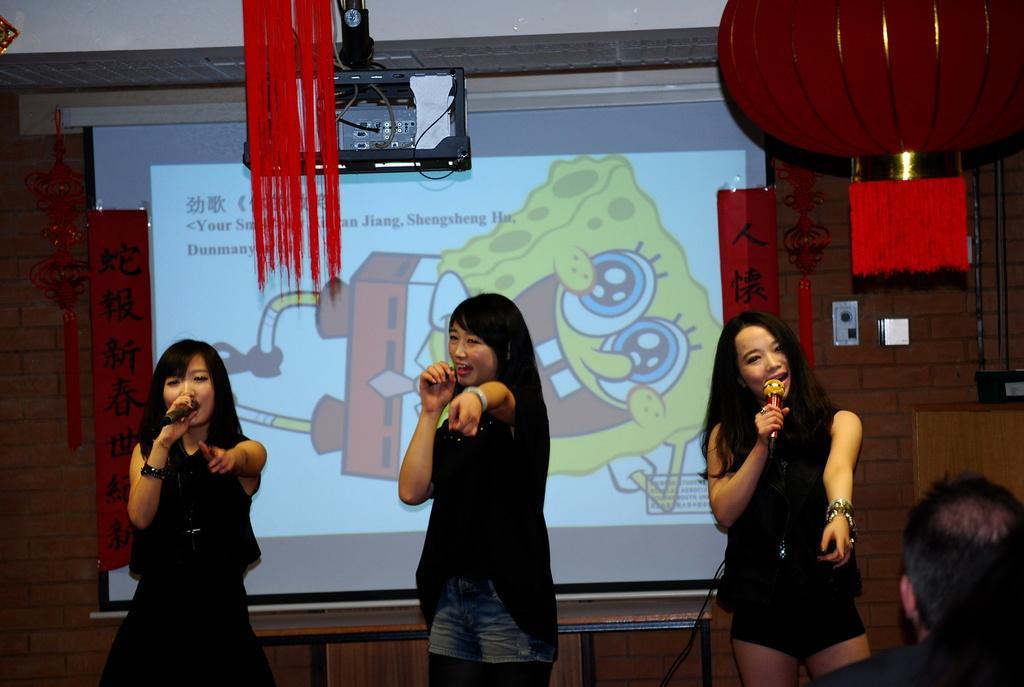Describe this image in one or two sentences. In this image I can see three person standing and holding mic. They are wearing black color dress. Back I can see screen and something is written on it. We can see a brick wall. In front I can see red color object. 